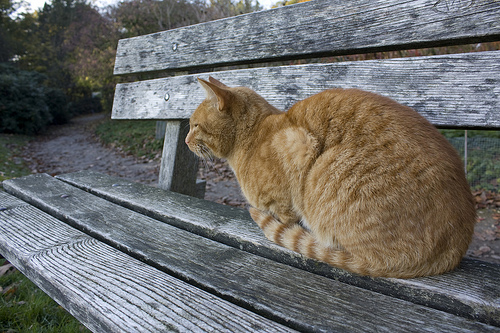Is the cat on a sofa? No, the cat is not on a sofa; it is on a bench. 